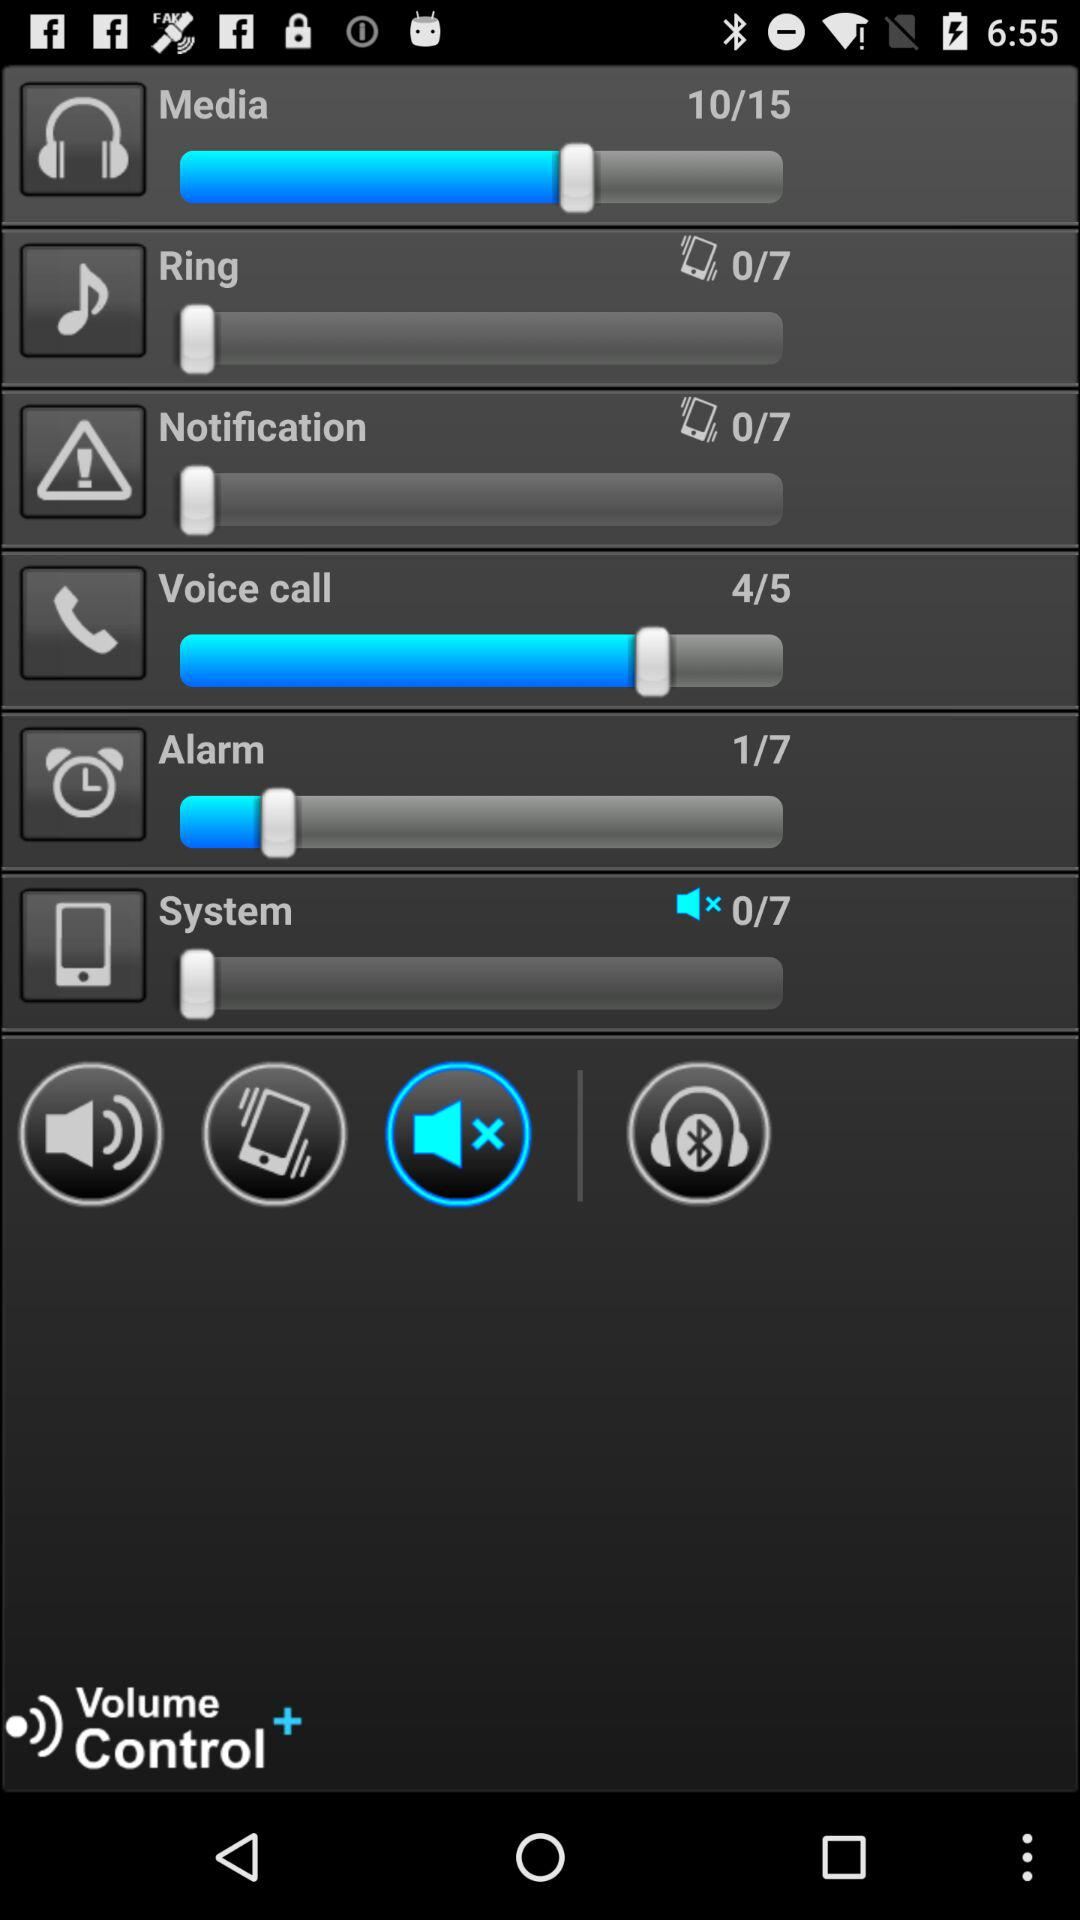What is the total number of system?
When the provided information is insufficient, respond with <no answer>. <no answer> 